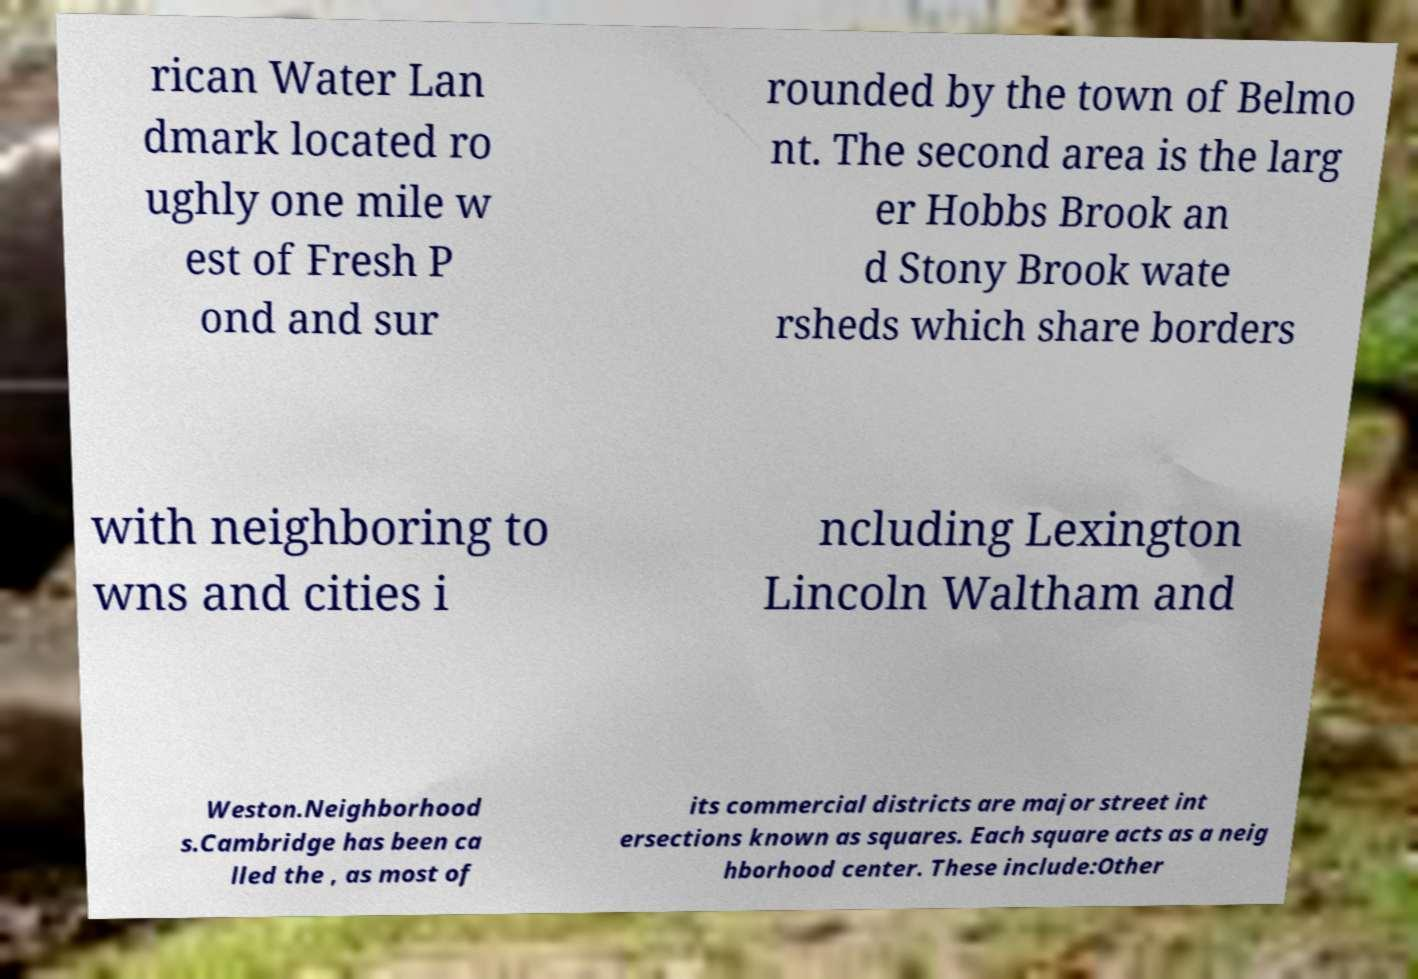Can you accurately transcribe the text from the provided image for me? rican Water Lan dmark located ro ughly one mile w est of Fresh P ond and sur rounded by the town of Belmo nt. The second area is the larg er Hobbs Brook an d Stony Brook wate rsheds which share borders with neighboring to wns and cities i ncluding Lexington Lincoln Waltham and Weston.Neighborhood s.Cambridge has been ca lled the , as most of its commercial districts are major street int ersections known as squares. Each square acts as a neig hborhood center. These include:Other 